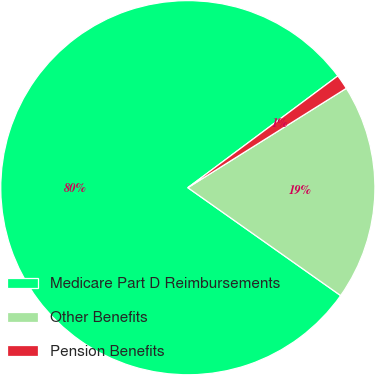Convert chart to OTSL. <chart><loc_0><loc_0><loc_500><loc_500><pie_chart><fcel>Medicare Part D Reimbursements<fcel>Other Benefits<fcel>Pension Benefits<nl><fcel>80.03%<fcel>18.7%<fcel>1.28%<nl></chart> 